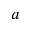Convert formula to latex. <formula><loc_0><loc_0><loc_500><loc_500>a</formula> 